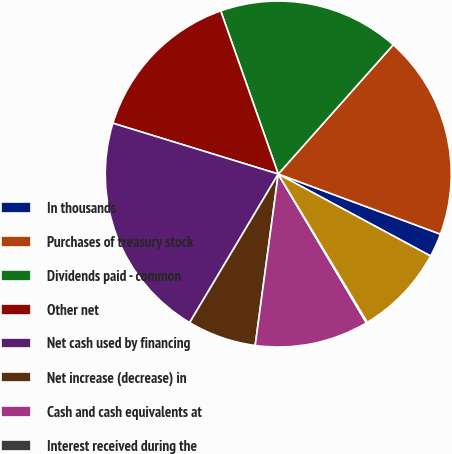Convert chart. <chart><loc_0><loc_0><loc_500><loc_500><pie_chart><fcel>In thousands<fcel>Purchases of treasury stock<fcel>Dividends paid - common<fcel>Other net<fcel>Net cash used by financing<fcel>Net increase (decrease) in<fcel>Cash and cash equivalents at<fcel>Interest received during the<fcel>Interest paid during the year<nl><fcel>2.21%<fcel>19.08%<fcel>16.97%<fcel>14.86%<fcel>21.19%<fcel>6.43%<fcel>10.64%<fcel>0.1%<fcel>8.53%<nl></chart> 